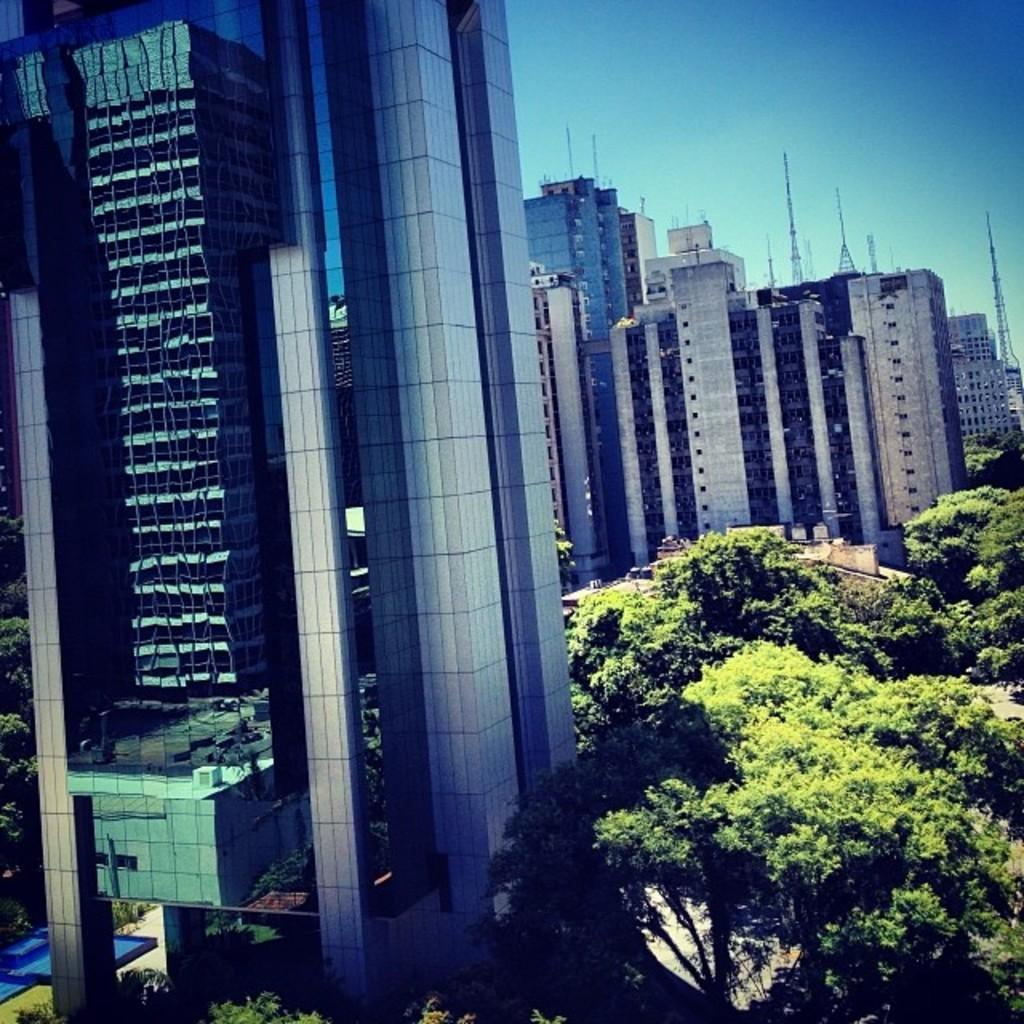What types of structures are present in the image? There are multiple buildings in the image. What other natural elements can be seen in the image? There are trees in the image. What is visible in the background of the image? The sky is visible in the background of the image. Are there any tall structures in the background of the image? Yes, there are towers in the background of the image. How many bombs can be seen in the image? There are no bombs present in the image. What type of cap is worn by the trees in the image? The trees in the image do not have caps; they are natural elements with leaves and branches. 